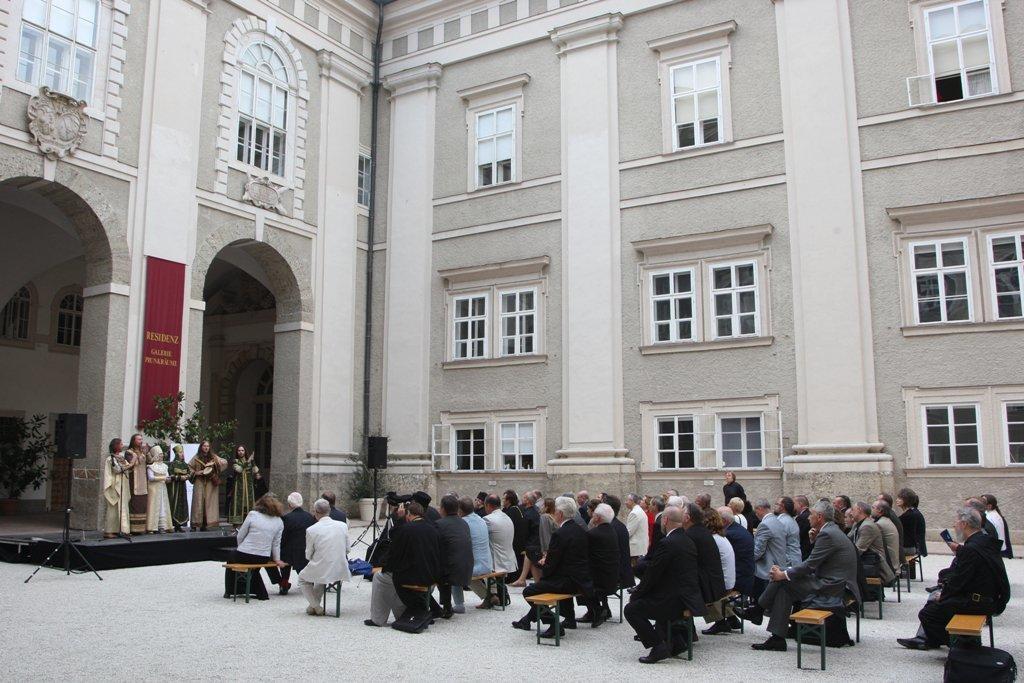Can you describe this image briefly? This is an outside view. Here I can see few people are sitting on the benches which are placed on the ground and looking at the people who is standing on the stage which is on the left side. On both sides of the stage I can see two speakers. In the background there is a building and some plants. 